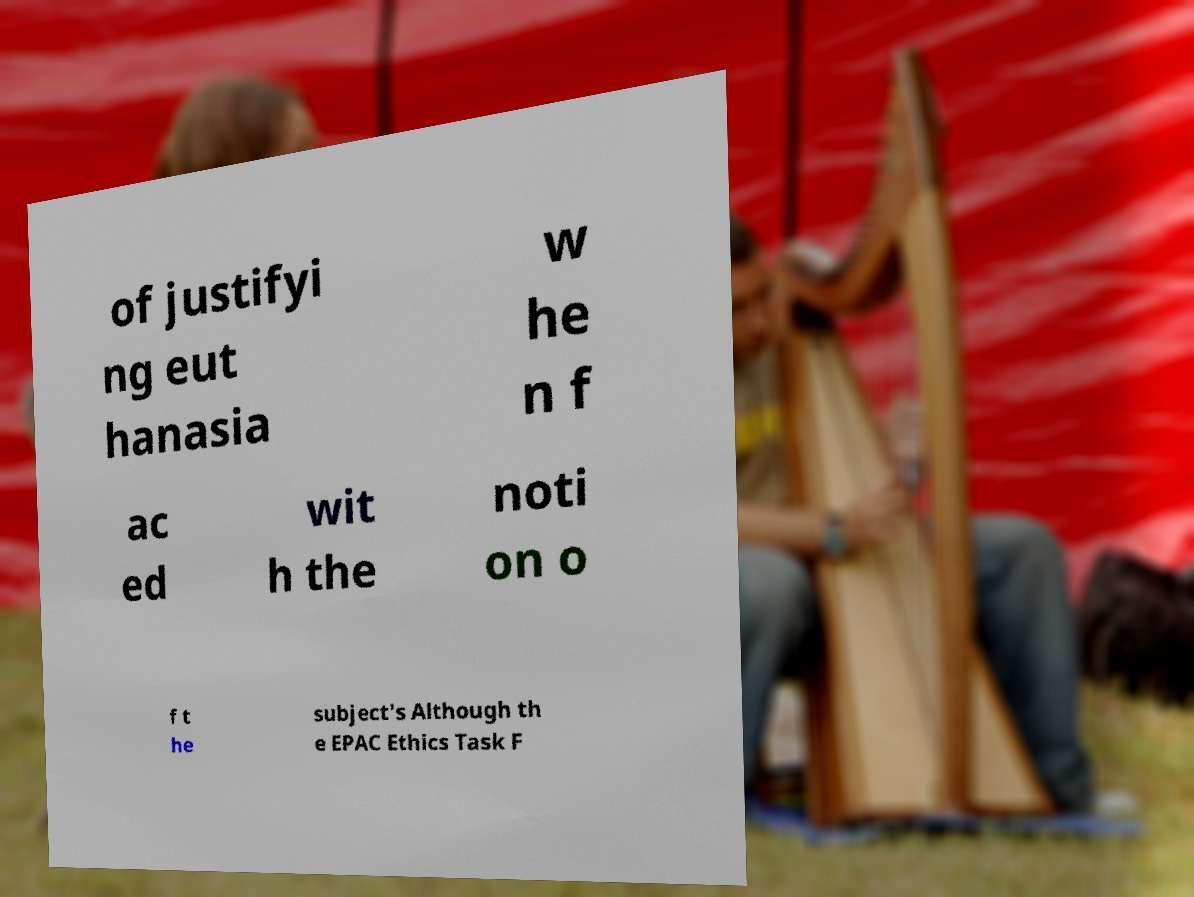Could you extract and type out the text from this image? of justifyi ng eut hanasia w he n f ac ed wit h the noti on o f t he subject's Although th e EPAC Ethics Task F 